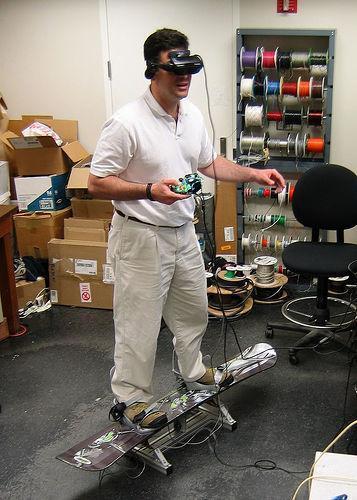How many purple spools of wire are in the picture?
Give a very brief answer. 1. 